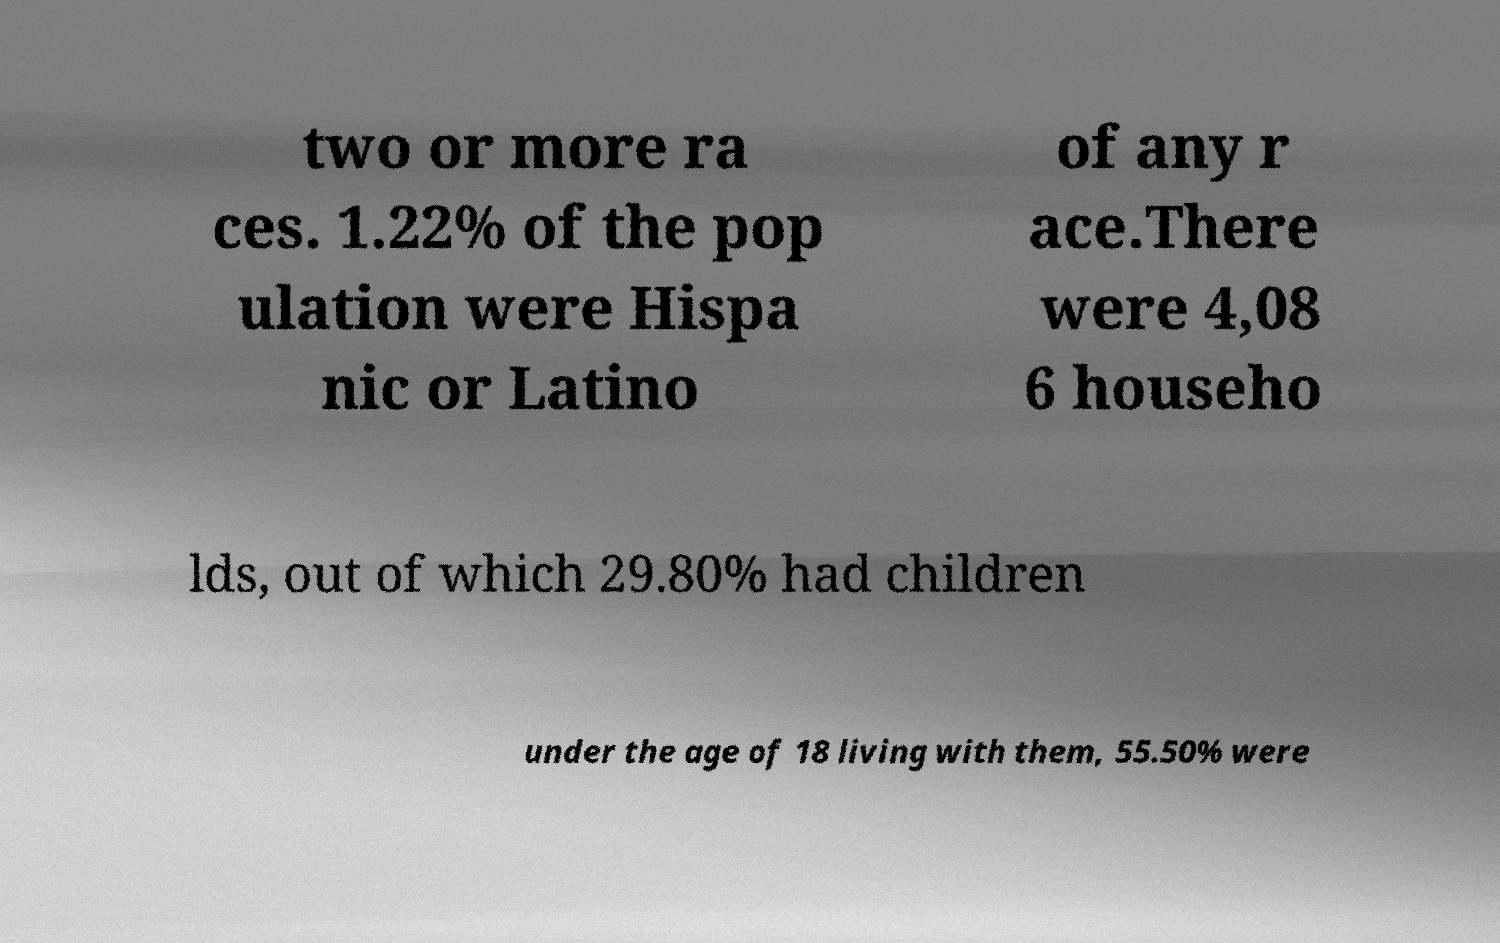I need the written content from this picture converted into text. Can you do that? two or more ra ces. 1.22% of the pop ulation were Hispa nic or Latino of any r ace.There were 4,08 6 househo lds, out of which 29.80% had children under the age of 18 living with them, 55.50% were 